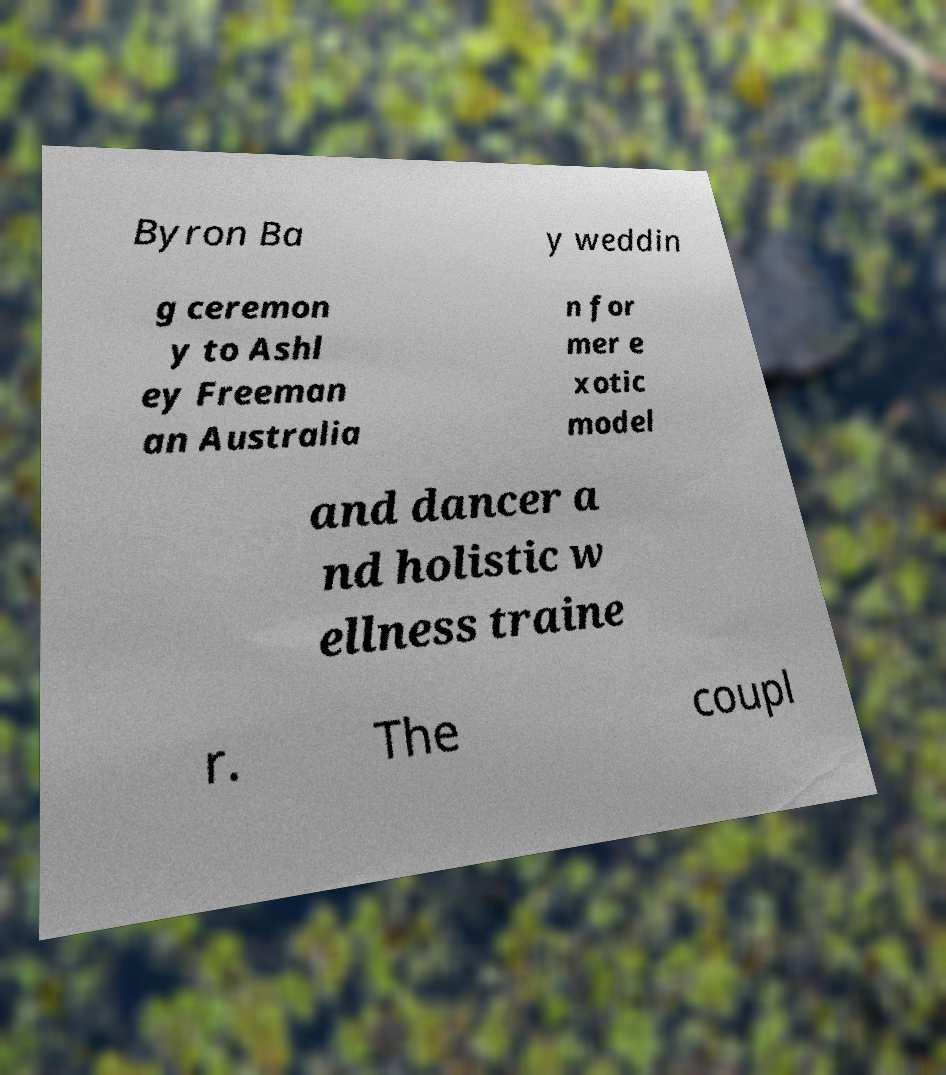Can you accurately transcribe the text from the provided image for me? Byron Ba y weddin g ceremon y to Ashl ey Freeman an Australia n for mer e xotic model and dancer a nd holistic w ellness traine r. The coupl 